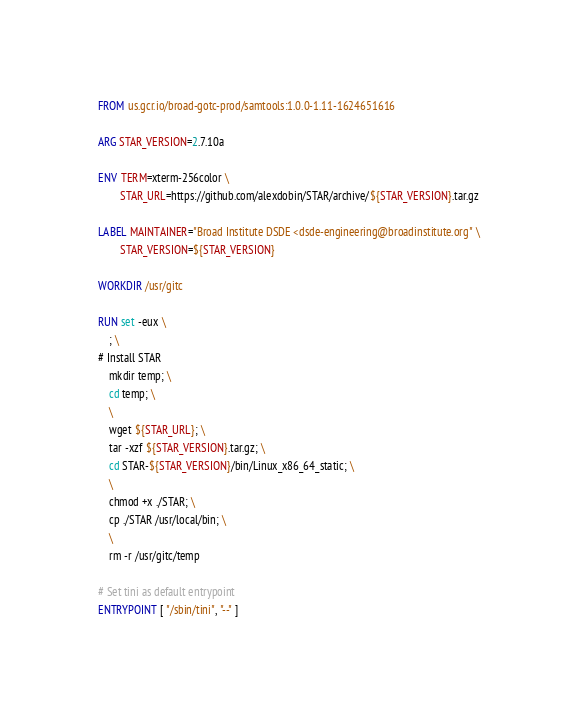<code> <loc_0><loc_0><loc_500><loc_500><_Dockerfile_>FROM us.gcr.io/broad-gotc-prod/samtools:1.0.0-1.11-1624651616

ARG STAR_VERSION=2.7.10a

ENV TERM=xterm-256color \
        STAR_URL=https://github.com/alexdobin/STAR/archive/${STAR_VERSION}.tar.gz

LABEL MAINTAINER="Broad Institute DSDE <dsde-engineering@broadinstitute.org" \
        STAR_VERSION=${STAR_VERSION}

WORKDIR /usr/gitc

RUN set -eux \
    ; \
# Install STAR
    mkdir temp; \
    cd temp; \
    \
    wget ${STAR_URL}; \
    tar -xzf ${STAR_VERSION}.tar.gz; \
    cd STAR-${STAR_VERSION}/bin/Linux_x86_64_static; \
    \
    chmod +x ./STAR; \
    cp ./STAR /usr/local/bin; \
    \
    rm -r /usr/gitc/temp

# Set tini as default entrypoint 
ENTRYPOINT [ "/sbin/tini", "--" ]
</code> 